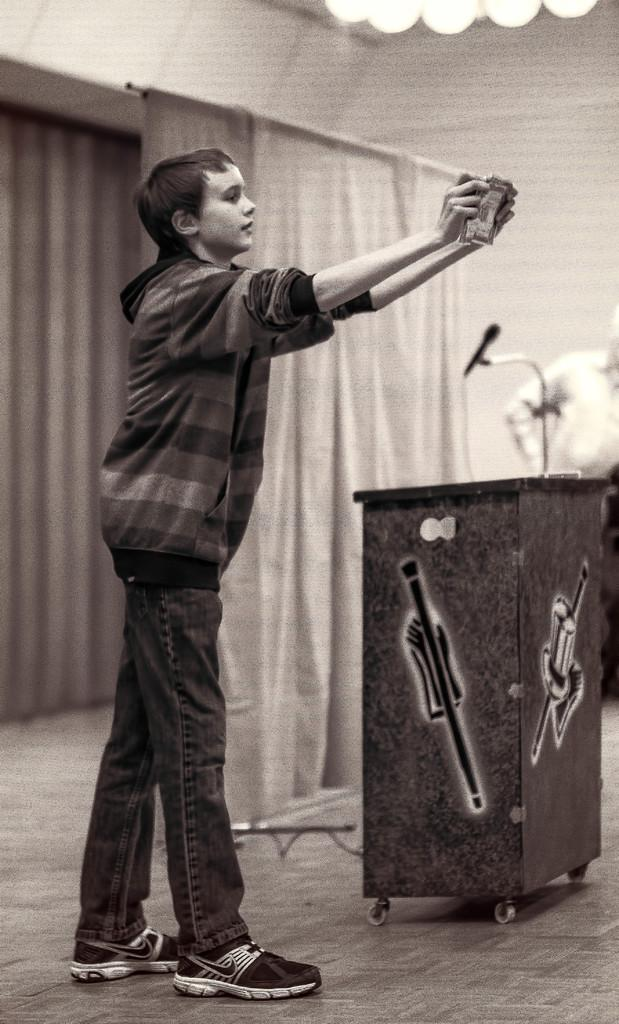Who is the main subject in the image? The main subject in the image is a boy. What is the boy doing in the image? The boy is standing on the ground and holding a book in his hand. What can be seen in the background of the image? There is a podium, a curtain, and a person in the background of the image. What type of punishment is the boy receiving in the image? There is no indication of punishment in the image; the boy is simply standing on the ground and holding a book. 